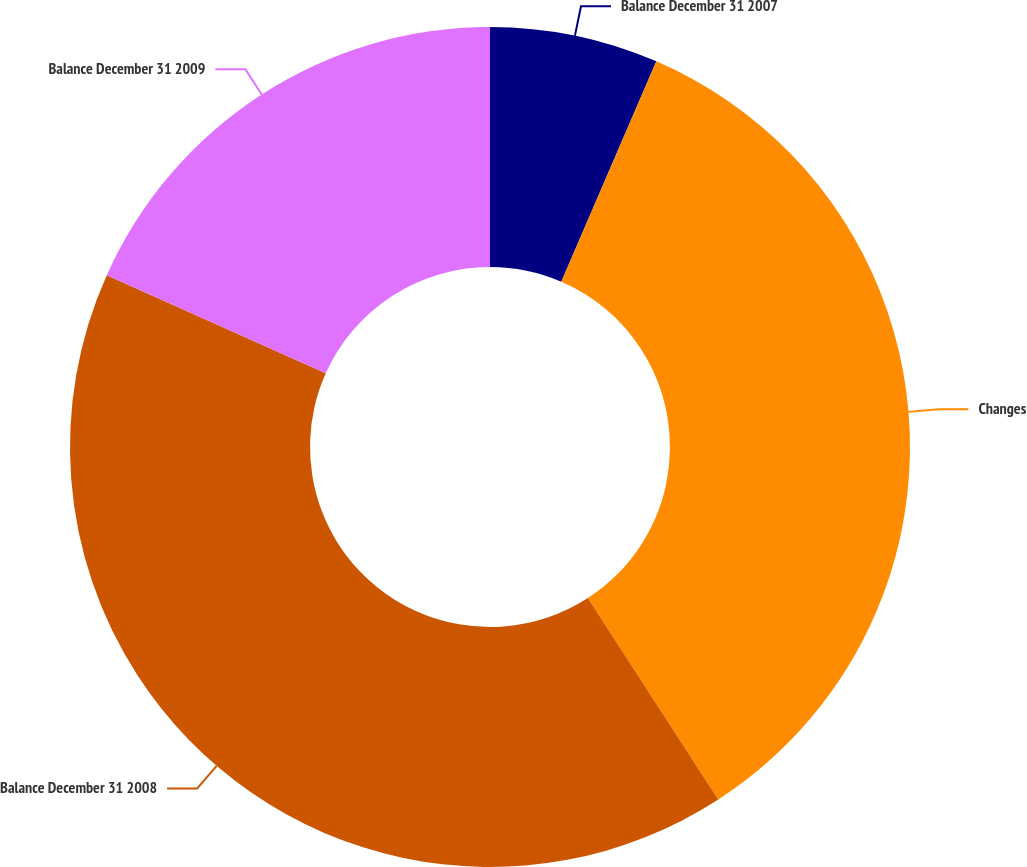Convert chart. <chart><loc_0><loc_0><loc_500><loc_500><pie_chart><fcel>Balance December 31 2007<fcel>Changes<fcel>Balance December 31 2008<fcel>Balance December 31 2009<nl><fcel>6.48%<fcel>34.37%<fcel>40.85%<fcel>18.29%<nl></chart> 